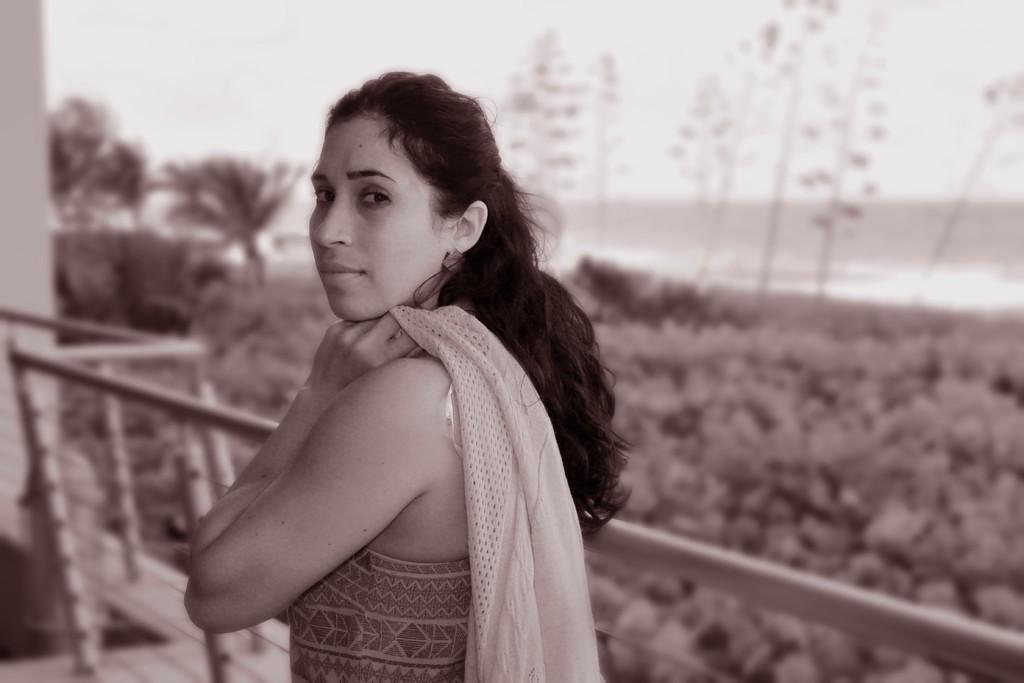What is the main subject of the image? There is a woman standing in the center of the image. What is the woman holding in the image? The woman is holding a cloth. What can be seen in the background of the image? There is sky, trees, and a fence visible in the background of the image. How many chickens are playing basketball in the image? There are no chickens or basketballs present in the image. What type of skirt is the woman wearing in the image? The image does not show the woman wearing a skirt; she is holding a cloth. 